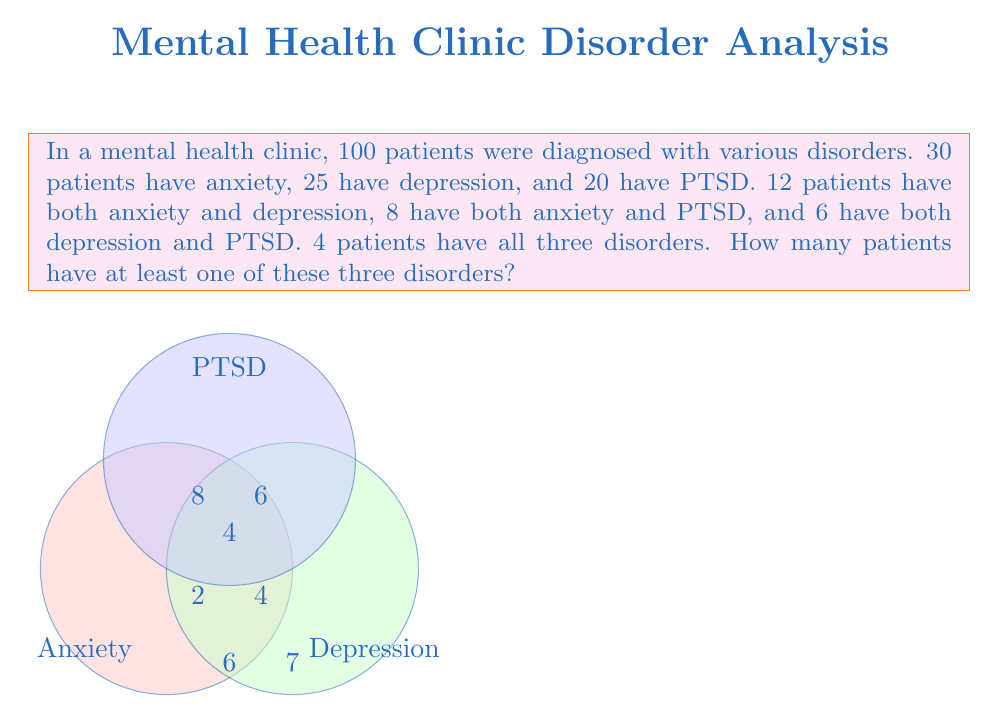Can you answer this question? Let's approach this step-by-step using the given Venn diagram and set theory:

1) First, let's identify the number of patients in each exclusive region of the Venn diagram:
   - Only Anxiety: $30 - 12 - 8 + 4 = 14$
   - Only Depression: $25 - 12 - 6 + 4 = 11$
   - Only PTSD: $20 - 8 - 6 + 4 = 10$
   - Anxiety and Depression only: $12 - 4 = 8$
   - Anxiety and PTSD only: $8 - 4 = 4$
   - Depression and PTSD only: $6 - 4 = 2$
   - All three: $4$

2) Now, let's use the principle of inclusion-exclusion to find the total number of patients with at least one disorder:

   $$|A \cup D \cup P| = |A| + |D| + |P| - |A \cap D| - |A \cap P| - |D \cap P| + |A \cap D \cap P|$$

   Where A = Anxiety, D = Depression, P = PTSD

3) Substituting the values:

   $$|A \cup D \cup P| = 30 + 25 + 20 - 12 - 8 - 6 + 4 = 53$$

Therefore, 53 patients have at least one of these three disorders.
Answer: 53 patients 